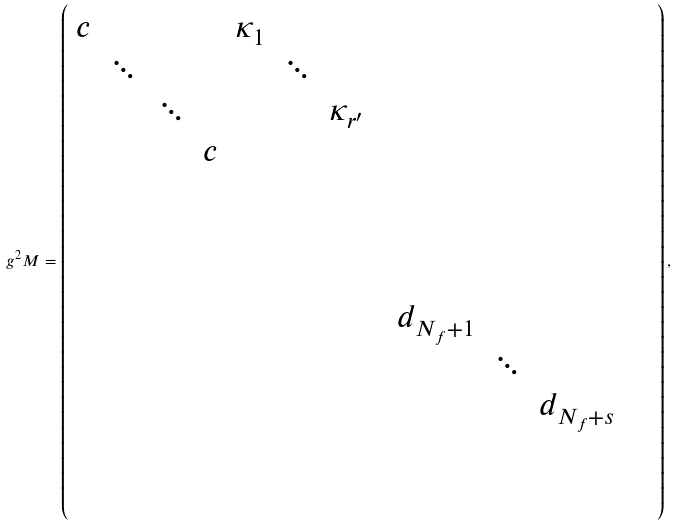<formula> <loc_0><loc_0><loc_500><loc_500>g ^ { 2 } M = \left ( \begin{array} { c c c c c c c c c c c c c } c & & & & \kappa _ { 1 } & & & & & & & & \\ & \ddots & & & & \ddots & & & & & & & \\ & & \ddots & & & & \kappa _ { r ^ { \prime } } & & & & & & \\ & & & c & & & & & & & & & \\ & & & & & & & & & & & & \\ & & & & & & & & & & & & \\ & & & & & & & & & & & & \\ & & & & & & & & d _ { N _ { f } + 1 } & & & & \\ & & & & & & & & & \ddots & & & \\ & & & & & & & & & & d _ { N _ { f } + s } & & \\ & & & & & & & & & & & & \\ & & & & & & & & & & & & \end{array} \right ) ,</formula> 